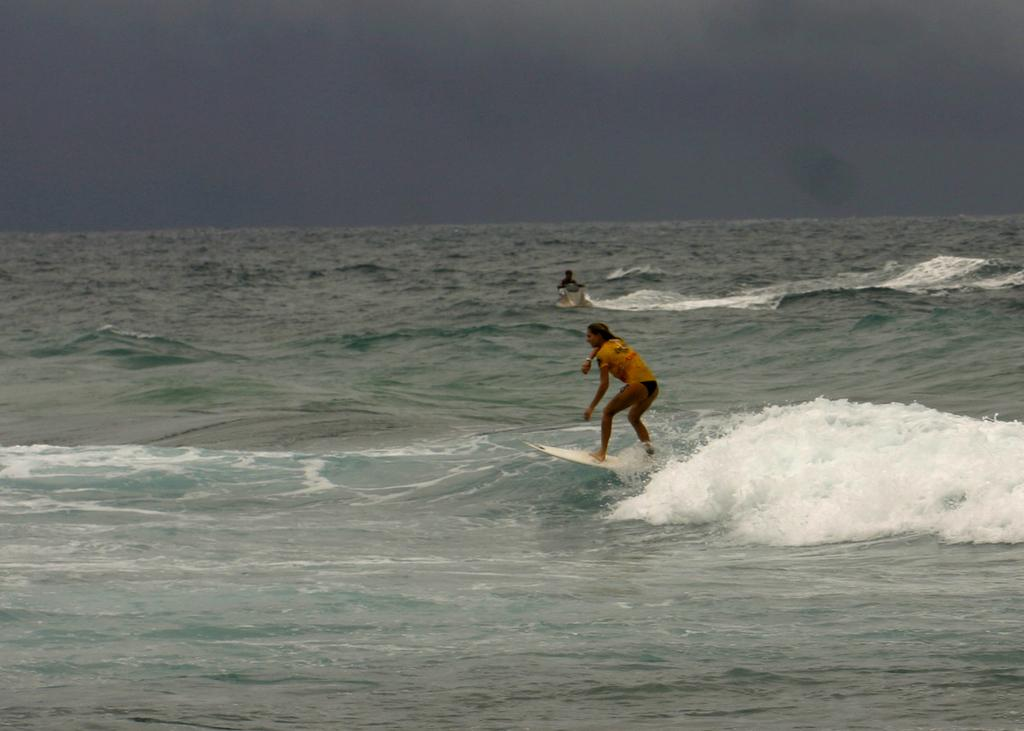What activity is the person in the image engaged in? The person is surfing on a surfboard in the image. Where is the person surfing? The person is on the ocean tide. Are there any other people in the image? Yes, there is another person in the ocean. What can be seen in the background of the image? The background of the image includes an ocean and the sky. What type of gold thread is being used by the person surfing in the image? There is no gold thread present in the image; the person is surfing on a surfboard in the ocean. Is the person's family visible in the image? There is no information about the person's family in the image, as it only shows the person surfing and another person in the ocean. 